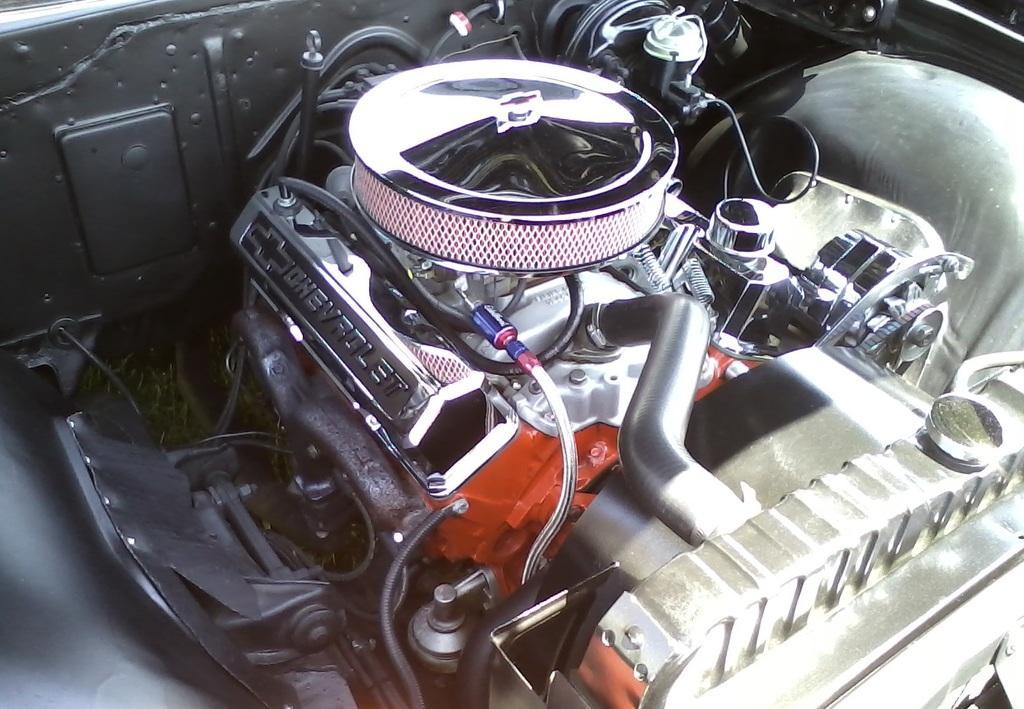Could you give a brief overview of what you see in this image? In this picture we can see engine of a vehicle. 